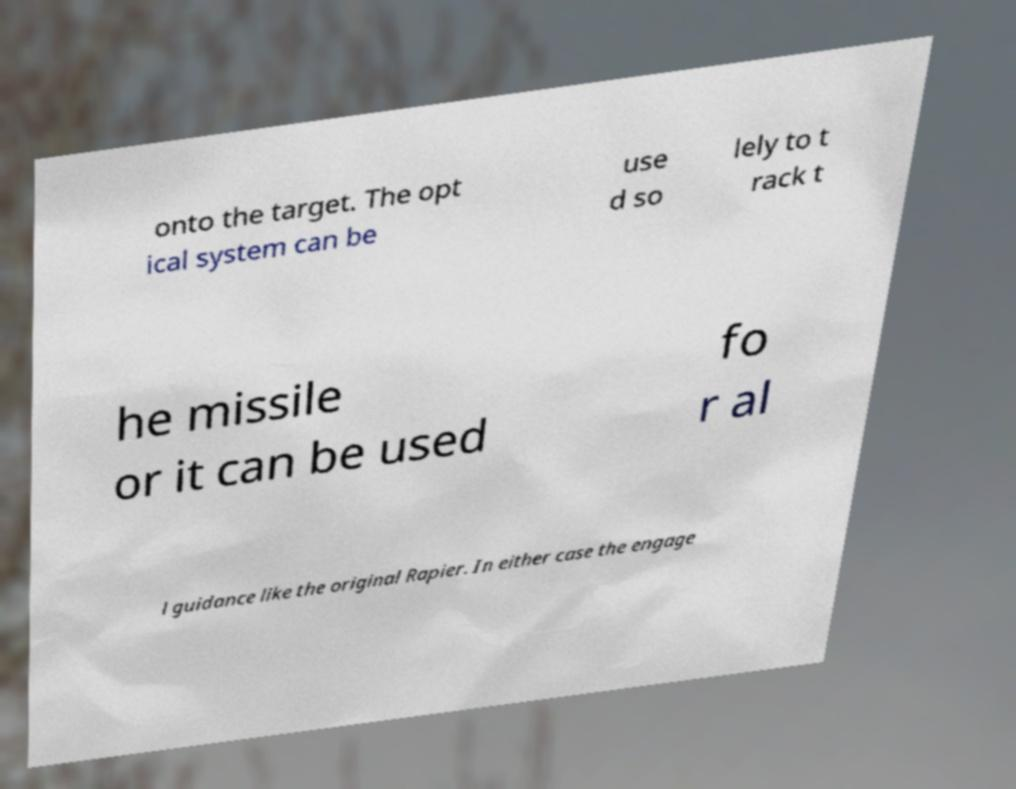For documentation purposes, I need the text within this image transcribed. Could you provide that? onto the target. The opt ical system can be use d so lely to t rack t he missile or it can be used fo r al l guidance like the original Rapier. In either case the engage 